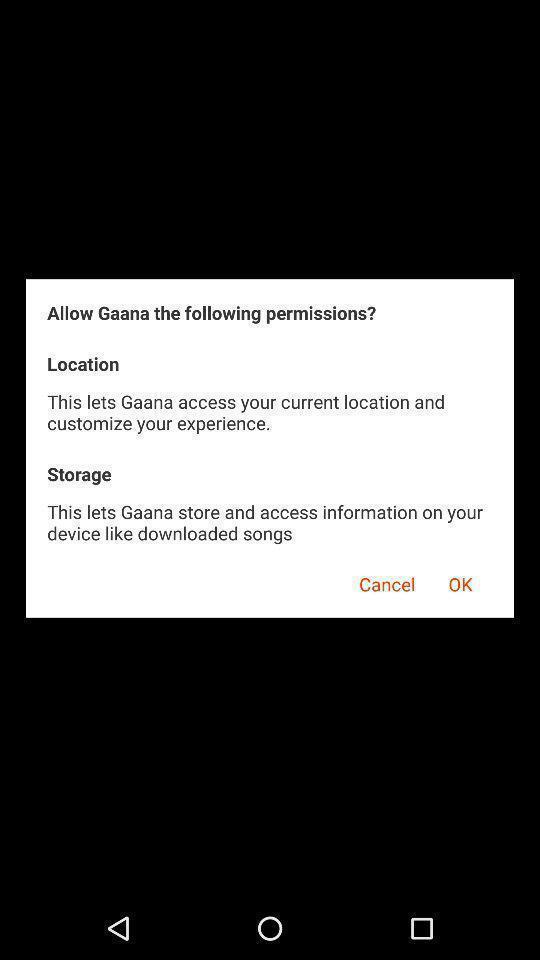Provide a textual representation of this image. Pop-up showing to allow permissions in a music app. 